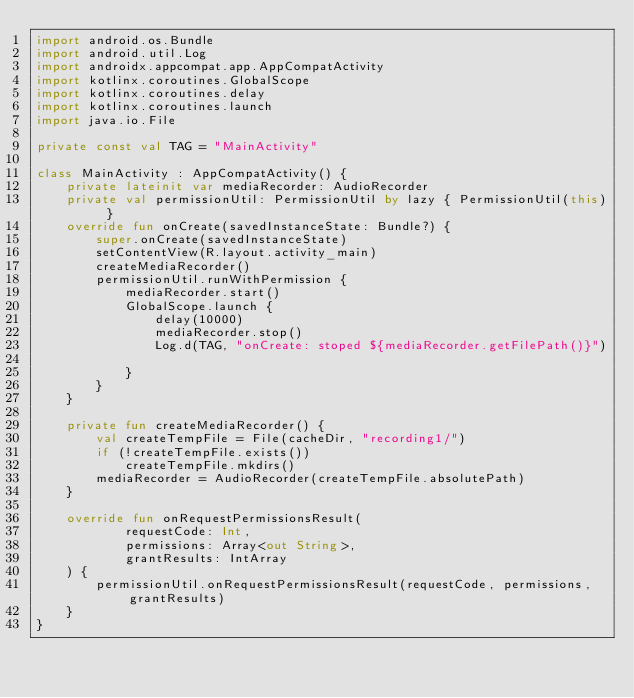<code> <loc_0><loc_0><loc_500><loc_500><_Kotlin_>import android.os.Bundle
import android.util.Log
import androidx.appcompat.app.AppCompatActivity
import kotlinx.coroutines.GlobalScope
import kotlinx.coroutines.delay
import kotlinx.coroutines.launch
import java.io.File

private const val TAG = "MainActivity"

class MainActivity : AppCompatActivity() {
    private lateinit var mediaRecorder: AudioRecorder
    private val permissionUtil: PermissionUtil by lazy { PermissionUtil(this) }
    override fun onCreate(savedInstanceState: Bundle?) {
        super.onCreate(savedInstanceState)
        setContentView(R.layout.activity_main)
        createMediaRecorder()
        permissionUtil.runWithPermission {
            mediaRecorder.start()
            GlobalScope.launch {
                delay(10000)
                mediaRecorder.stop()
                Log.d(TAG, "onCreate: stoped ${mediaRecorder.getFilePath()}")

            }
        }
    }

    private fun createMediaRecorder() {
        val createTempFile = File(cacheDir, "recording1/")
        if (!createTempFile.exists())
            createTempFile.mkdirs()
        mediaRecorder = AudioRecorder(createTempFile.absolutePath)
    }

    override fun onRequestPermissionsResult(
            requestCode: Int,
            permissions: Array<out String>,
            grantResults: IntArray
    ) {
        permissionUtil.onRequestPermissionsResult(requestCode, permissions, grantResults)
    }
}</code> 